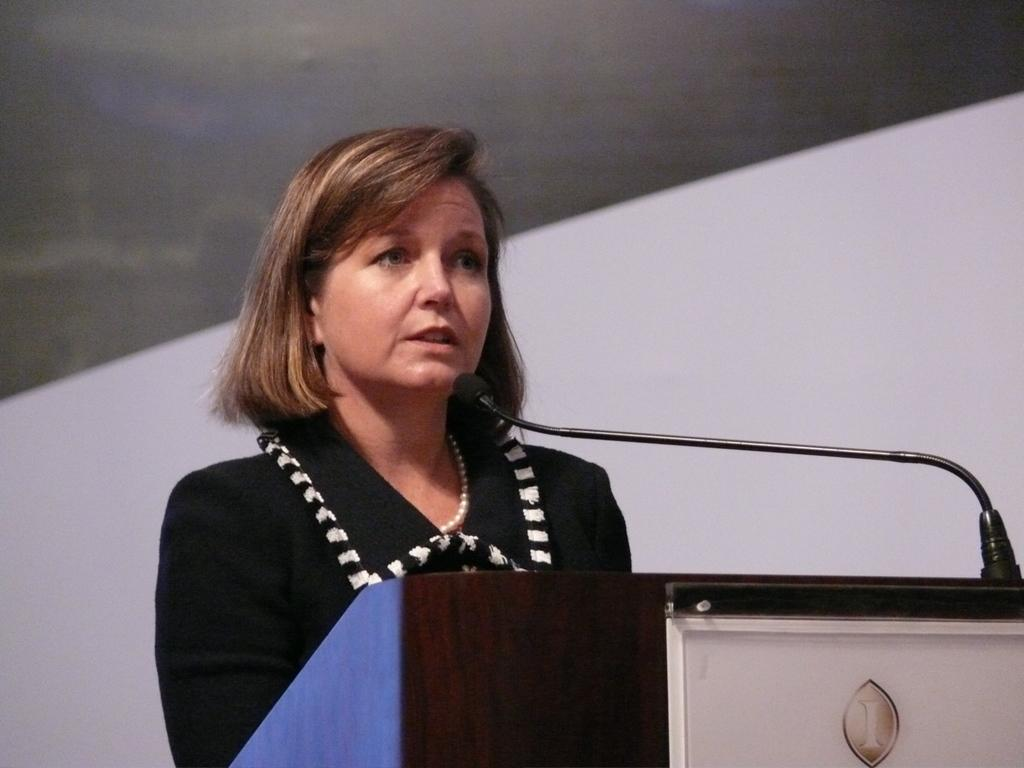Who is the main subject in the image? There is a woman in the image. What is the woman wearing? The woman is wearing a black dress. What is the woman doing in the image? The woman is talking into a microphone. Where is the woman standing in the image? The woman is standing in front of a dias. What is visible behind the woman? There is a wall behind the woman. What type of screw is the woman using to attach the crown in the image? There is no screw or crown present in the image; the woman is talking into a microphone while standing in front of a dias. 